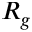<formula> <loc_0><loc_0><loc_500><loc_500>R _ { g }</formula> 